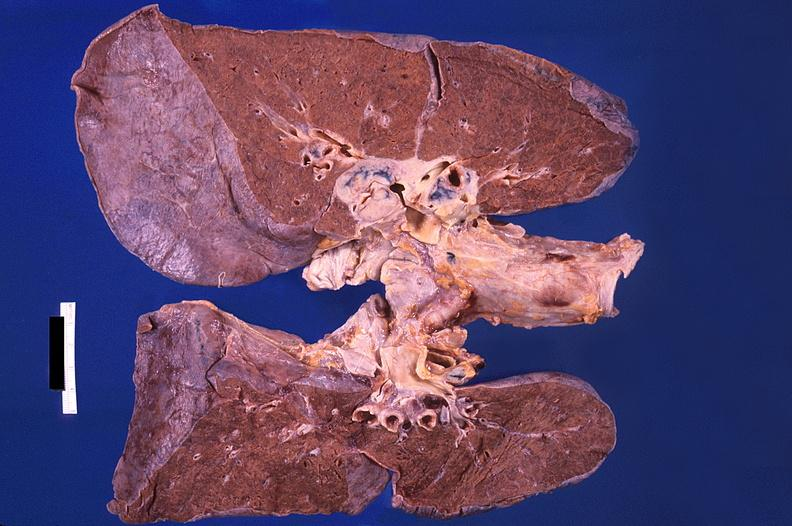where is this?
Answer the question using a single word or phrase. Lung 